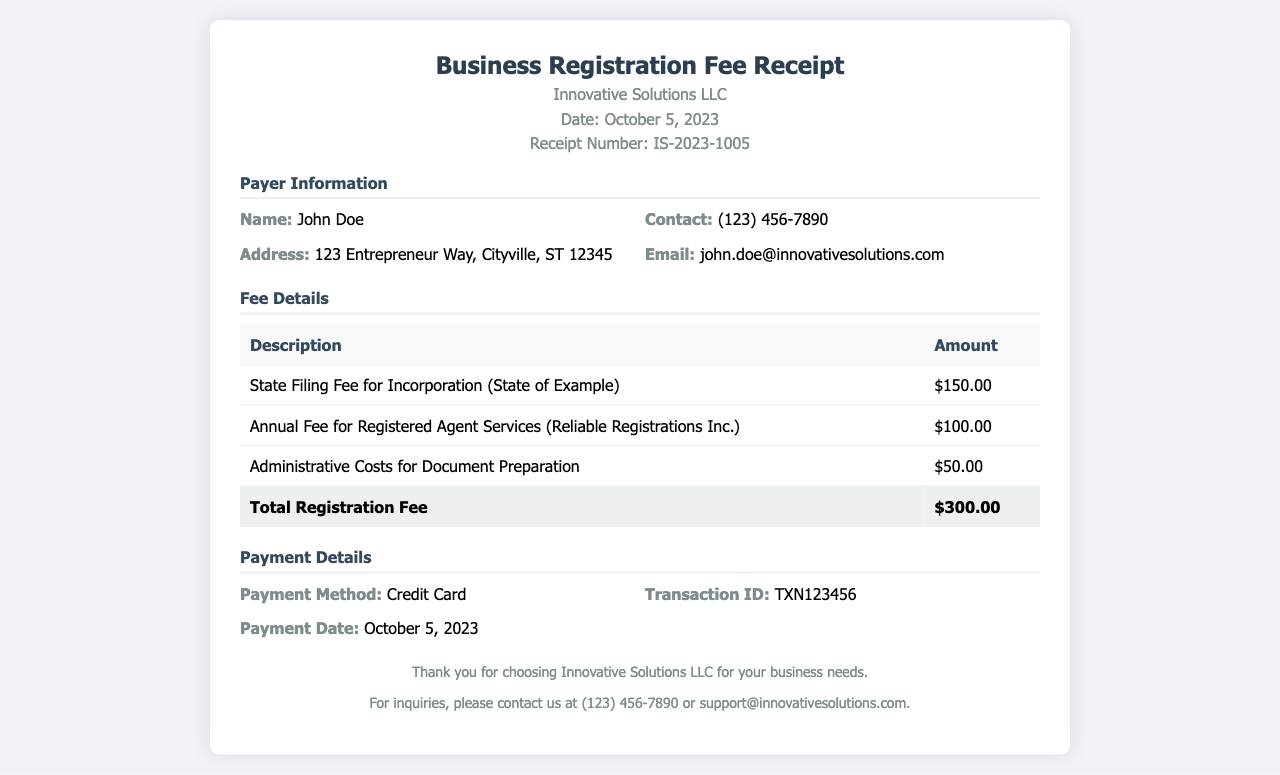What is the name of the business? The document states the name of the business is Innovative Solutions LLC.
Answer: Innovative Solutions LLC What is the total registration fee? The total registration fee is indicated at the bottom of the fee table.
Answer: $300.00 Who is the payer's contact? The payer's contact information is listed under Payer Information.
Answer: (123) 456-7890 When was the payment made? The payment date is provided in the Payment Details section.
Answer: October 5, 2023 How much is the State Filing Fee for Incorporation? The fee for State Filing Fee for Incorporation is specifically mentioned in the fee details.
Answer: $150.00 What is the Transaction ID? The Transaction ID is noted in the Payment Details section for reference.
Answer: TXN123456 What is the name of the registered agent? The name of the registered agent is specified in the fee details.
Answer: Reliable Registrations Inc How much is charged for Administrative Costs? The cost for Administrative Costs is shown in the fee table.
Answer: $50.00 What is the receipt number? The receipt number is mentioned at the header of the document.
Answer: IS-2023-1005 